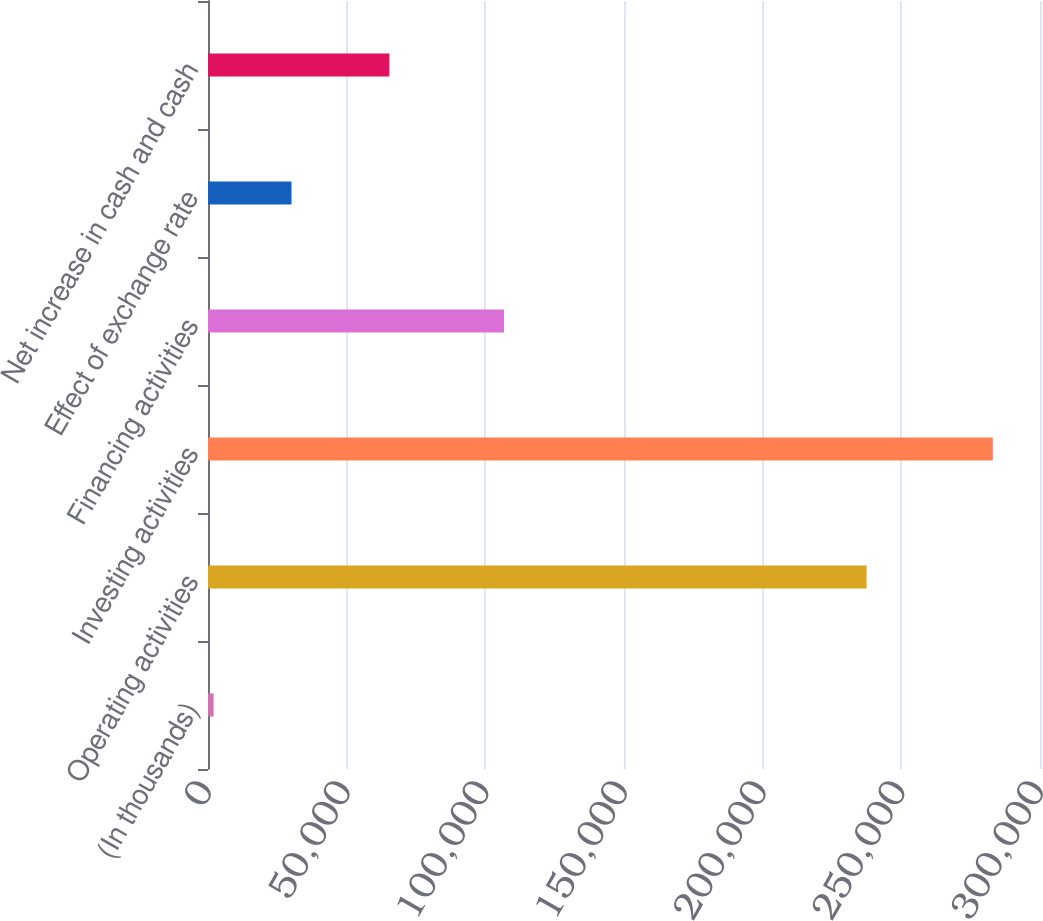Convert chart to OTSL. <chart><loc_0><loc_0><loc_500><loc_500><bar_chart><fcel>(In thousands)<fcel>Operating activities<fcel>Investing activities<fcel>Financing activities<fcel>Effect of exchange rate<fcel>Net increase in cash and cash<nl><fcel>2017<fcel>237460<fcel>282987<fcel>106759<fcel>30114<fcel>65410<nl></chart> 